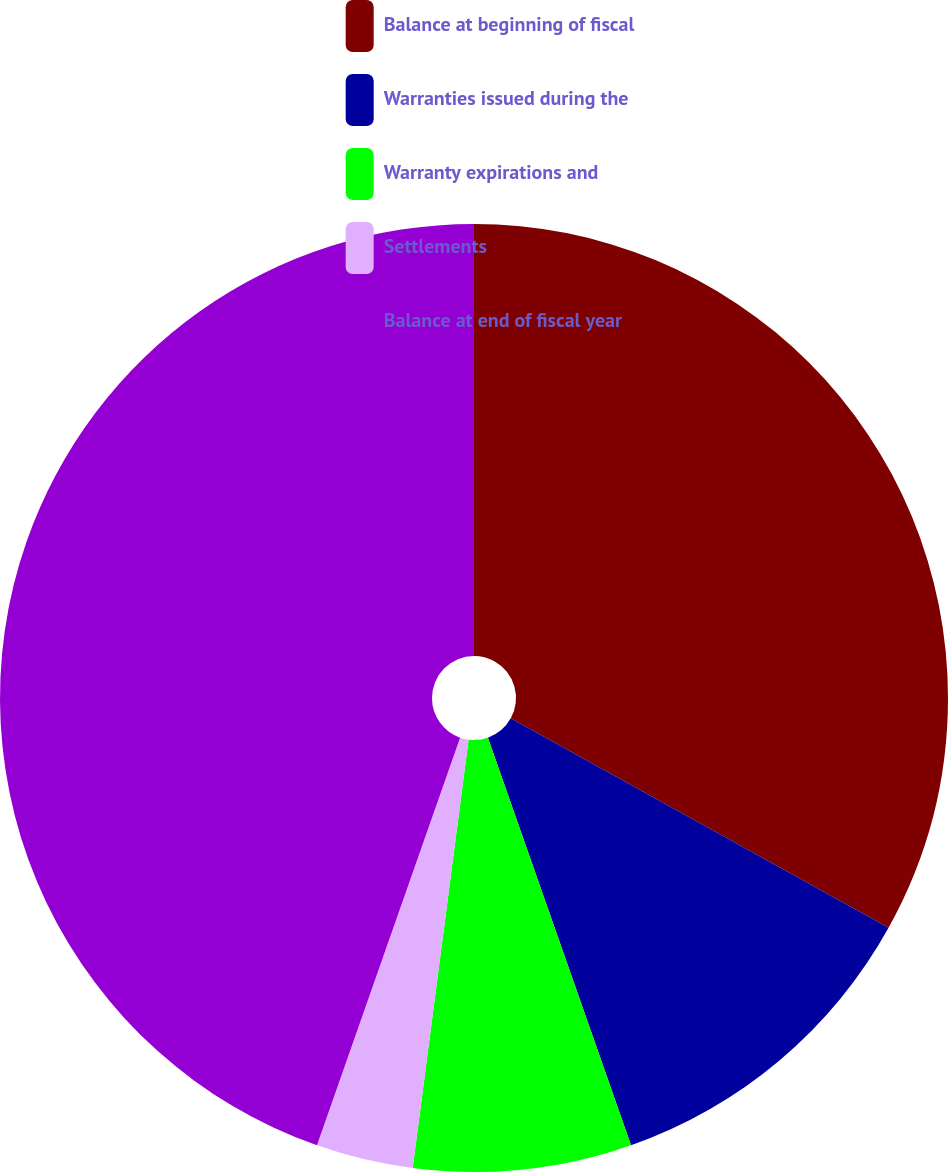Convert chart to OTSL. <chart><loc_0><loc_0><loc_500><loc_500><pie_chart><fcel>Balance at beginning of fiscal<fcel>Warranties issued during the<fcel>Warranty expirations and<fcel>Settlements<fcel>Balance at end of fiscal year<nl><fcel>33.06%<fcel>11.57%<fcel>7.44%<fcel>3.31%<fcel>44.63%<nl></chart> 